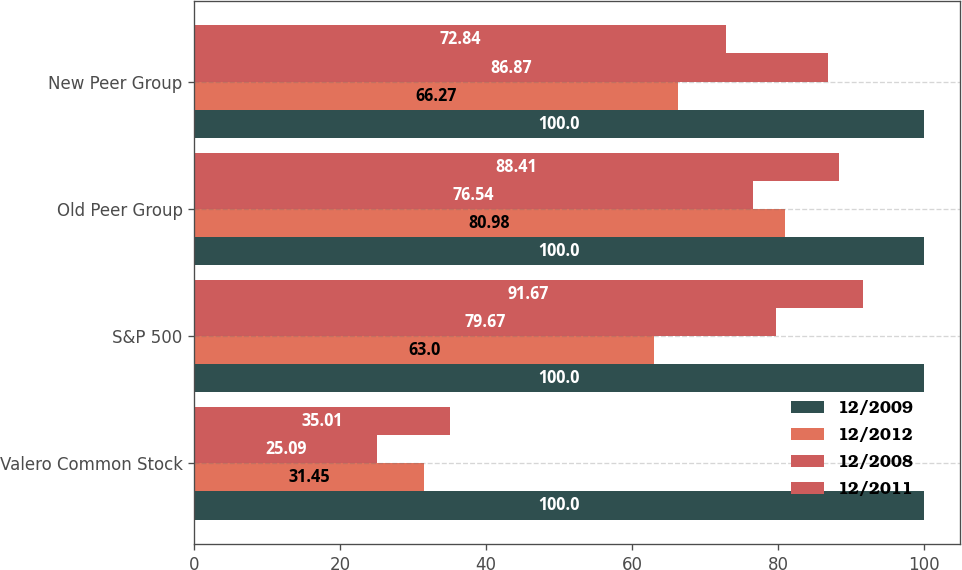Convert chart to OTSL. <chart><loc_0><loc_0><loc_500><loc_500><stacked_bar_chart><ecel><fcel>Valero Common Stock<fcel>S&P 500<fcel>Old Peer Group<fcel>New Peer Group<nl><fcel>12/2009<fcel>100<fcel>100<fcel>100<fcel>100<nl><fcel>12/2012<fcel>31.45<fcel>63<fcel>80.98<fcel>66.27<nl><fcel>12/2008<fcel>25.09<fcel>79.67<fcel>76.54<fcel>86.87<nl><fcel>12/2011<fcel>35.01<fcel>91.67<fcel>88.41<fcel>72.84<nl></chart> 